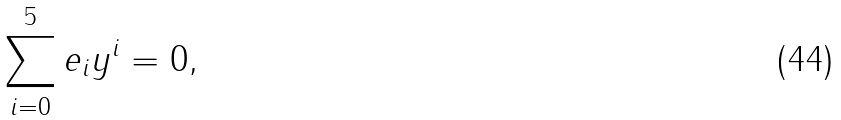<formula> <loc_0><loc_0><loc_500><loc_500>\sum _ { i = 0 } ^ { 5 } e _ { i } y ^ { i } = 0 ,</formula> 